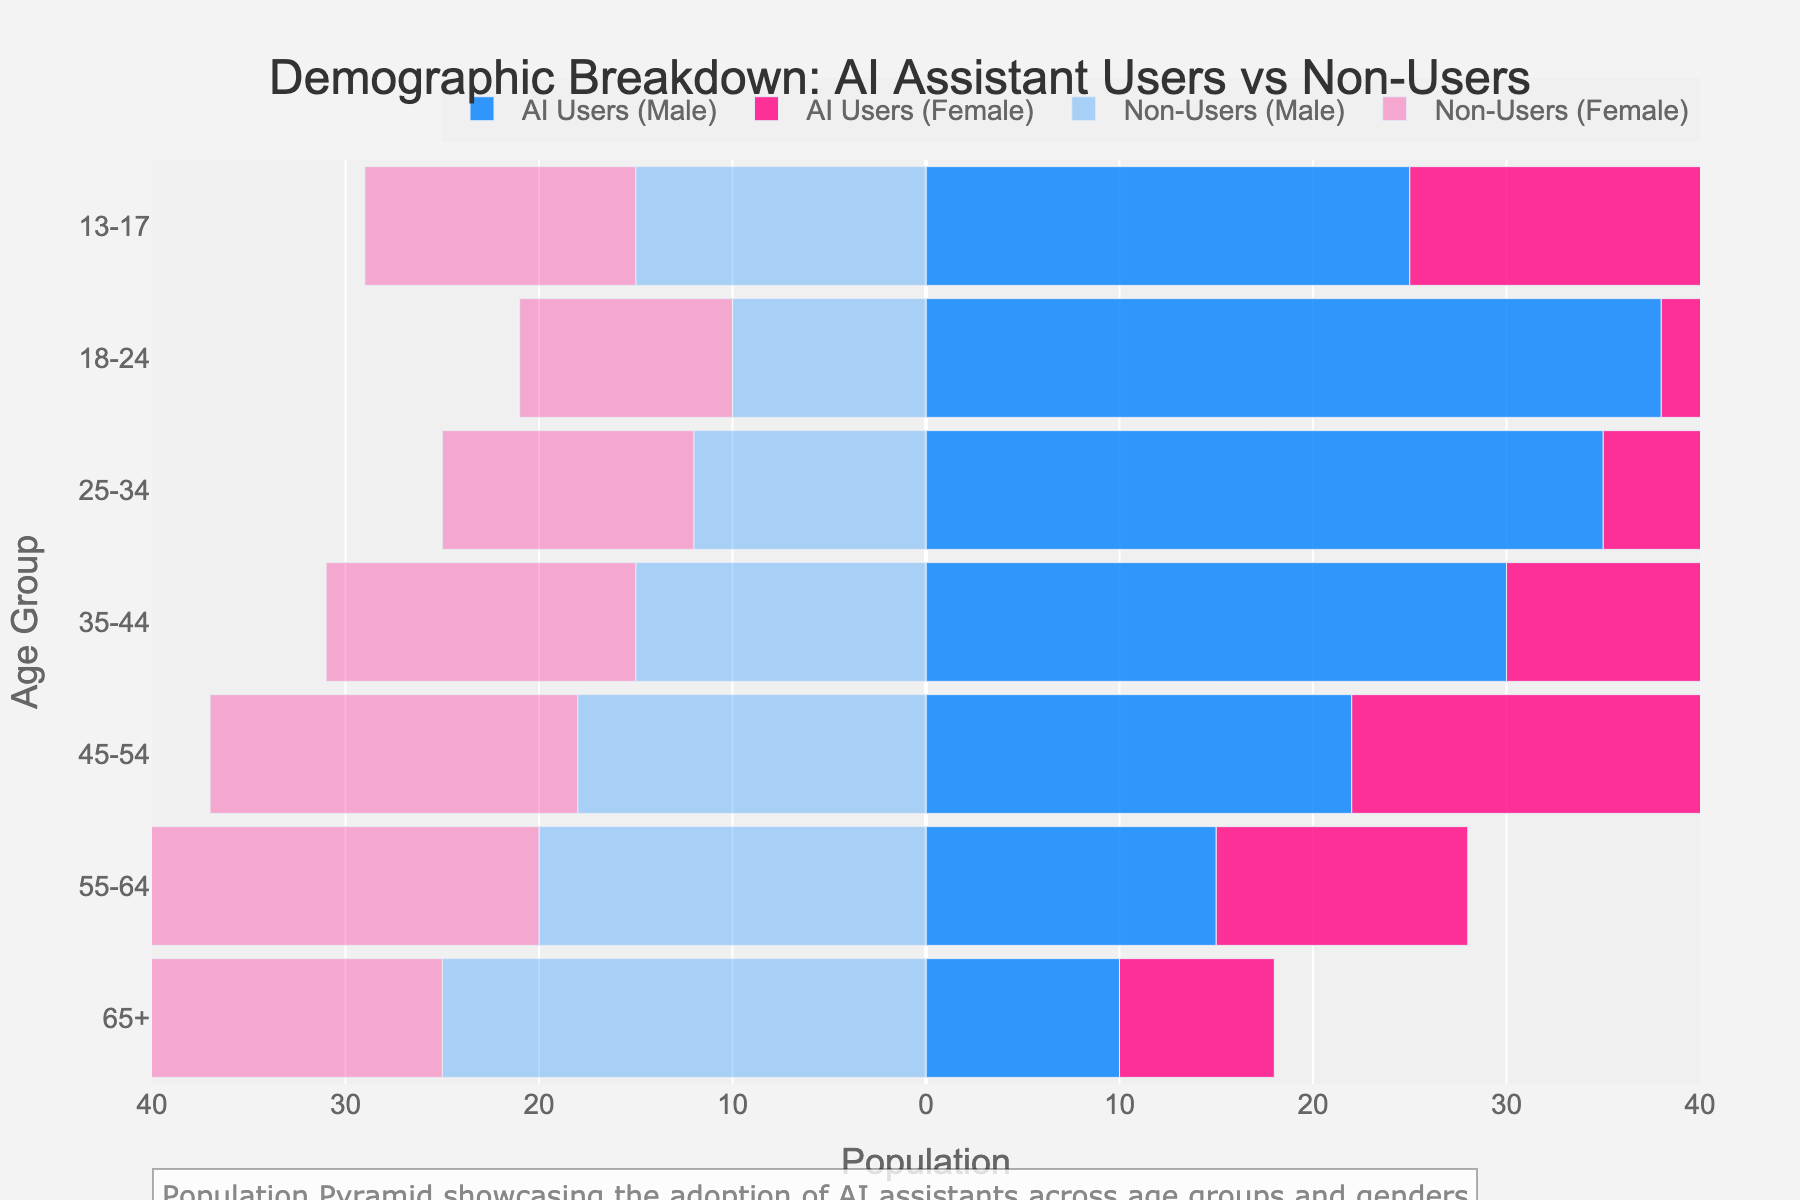What's the title of the plot? The title is displayed at the top of the plot. It is concise and gives an overview of the data being visualized.
Answer: Demographic Breakdown: AI Assistant Users vs Non-Users Which age group has the highest number of AI user males? To find the age group with the highest number of AI user males, look for the longest bar in the section corresponding to AI user males. The 18-24 age group extends furthest.
Answer: 18-24 In the 35-44 age group, what is the total number of AI users? Add the number of AI user males and AI user females for the 35-44 age group. AI user males are 30 and AI user females are 28. Therefore, the total is 30 + 28.
Answer: 58 How do the numbers of AI user and non-user females compare in the 55-64 age group? Compare the length of the bars for AI user females and non-user females in the 55-64 age group. AI user females are 13 and non-user females are 22.
Answer: Non-user females are more What is the ratio of AI user males to non-user males in the 25-34 age group? Divide the number of AI user males by the number of non-user males in the 25-34 age group. AI user males are 35 and non-user males are 12. The ratio is 35/12.
Answer: 35:12 Which group has the larger population: non-user females in the 13-17 age group or AI user males in the 65+ age group? Compare the lengths of the bars for non-user females in the 13-17 age group and AI user males in the 65+ age group. Non-user females are 14 and AI user males are 10.
Answer: Non-user females in 13-17 Calculate the average number of AI user females in the age groups from 35-44 to 18-24. Add the number of AI user females in each age group from 35-44 to 18-24 and then divide by the number of these age groups. The values are 28, 33, and 36. The sum is 28 + 33 + 36 = 97. The number of groups is 3. Therefore, the average is 97/3.
Answer: 32.33 Is the population of AI user males in the 45-54 age group equal to the population of non-user males in the same age group? Compare the lengths of the bars for AI user males and non-user males in the 45-54 age group. AI user males are 22 and non-user males are 18.
Answer: No What's the trend in AI user adoption from younger to older age groups for both genders? Observe the general direction of the bars representing AI users from younger to older age groups. The bars for both males and females decrease in length as the age groups increase.
Answer: Decreasing trend 